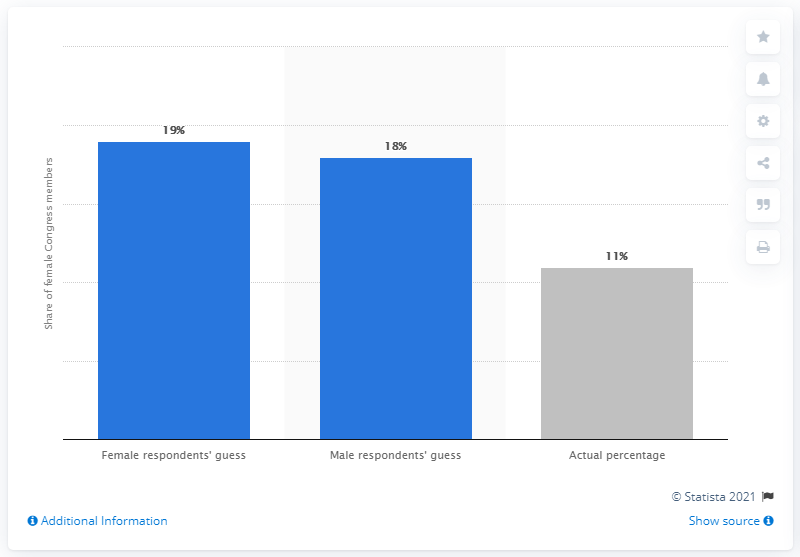Identify some key points in this picture. Only 11% of the Brazilian lawmakers are women. 